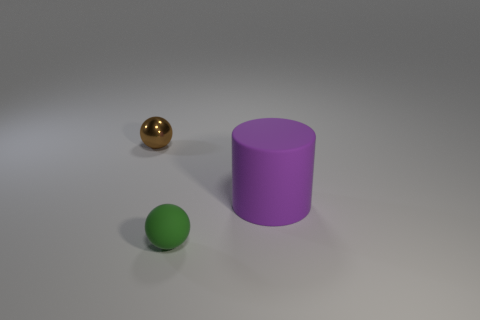Add 2 large metallic cylinders. How many objects exist? 5 Subtract all spheres. How many objects are left? 1 Add 1 brown cylinders. How many brown cylinders exist? 1 Subtract 0 yellow cubes. How many objects are left? 3 Subtract all small red rubber cylinders. Subtract all tiny shiny things. How many objects are left? 2 Add 1 matte things. How many matte things are left? 3 